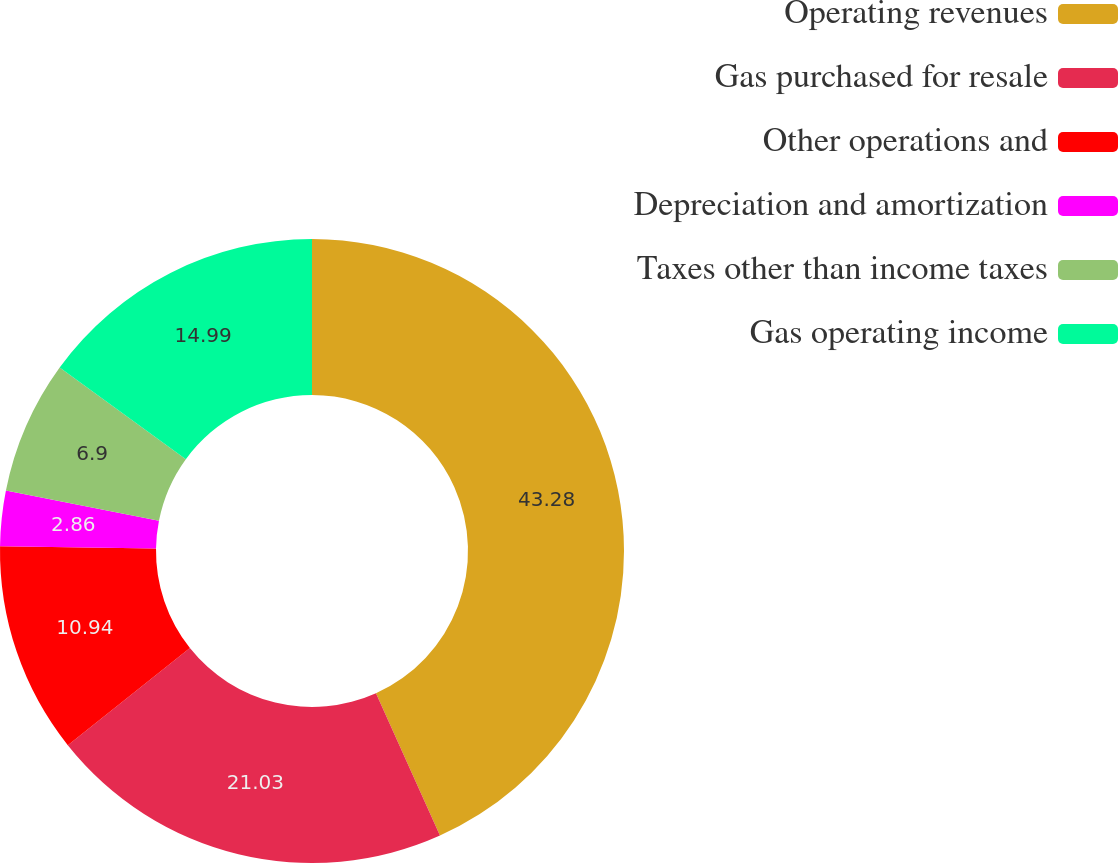Convert chart. <chart><loc_0><loc_0><loc_500><loc_500><pie_chart><fcel>Operating revenues<fcel>Gas purchased for resale<fcel>Other operations and<fcel>Depreciation and amortization<fcel>Taxes other than income taxes<fcel>Gas operating income<nl><fcel>43.27%<fcel>21.03%<fcel>10.94%<fcel>2.86%<fcel>6.9%<fcel>14.99%<nl></chart> 